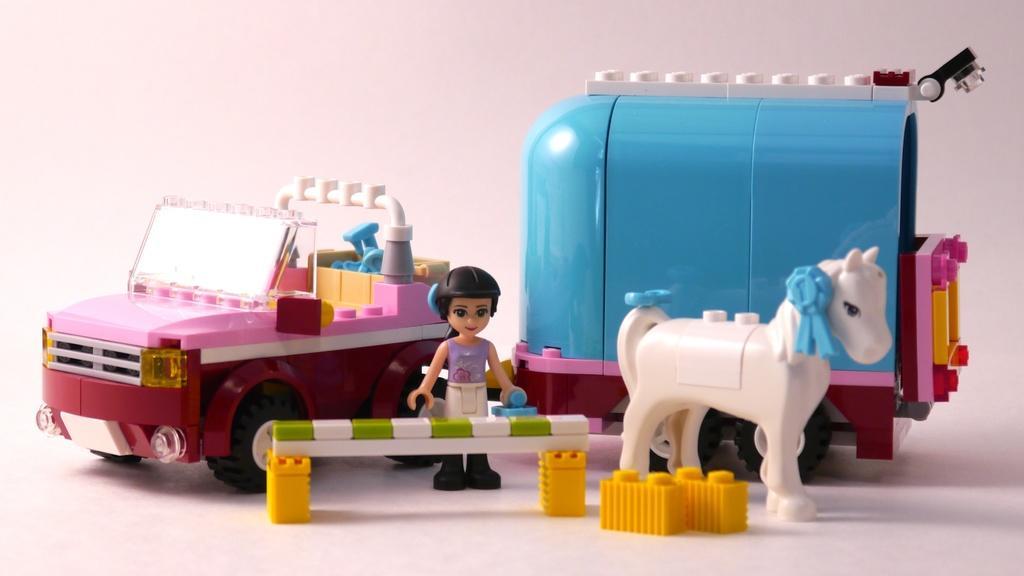Could you give a brief overview of what you see in this image? In this image there are some toys, and at the bottom there is a floor. 